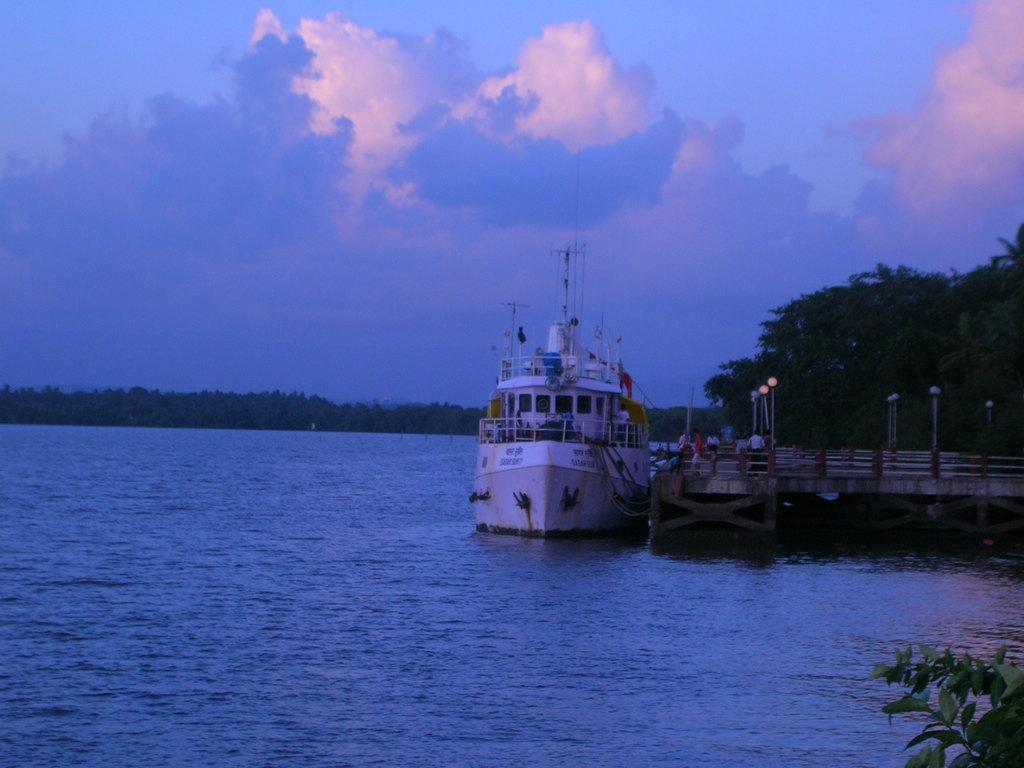Please provide a concise description of this image. In this image we can see the boat on the surface of the river. We can also see the bridge with light poles and also the people. Image also consists of trees and in the background we can see the sky with some clouds. 